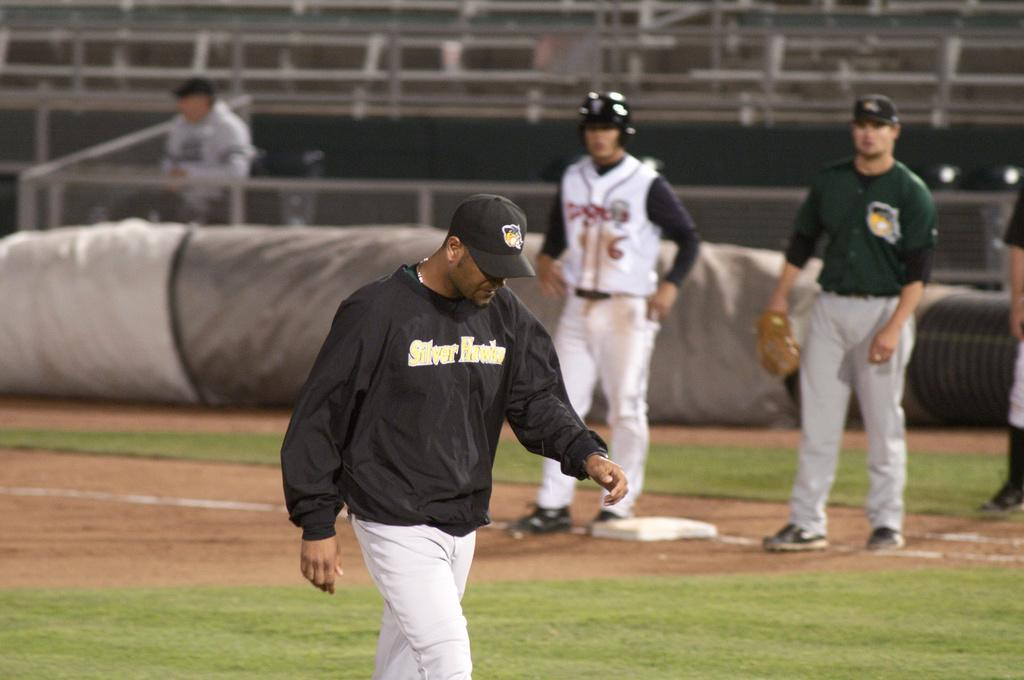Provide a one-sentence caption for the provided image. Baseball player wearing a sweater that says Silver Falcons on the front. 